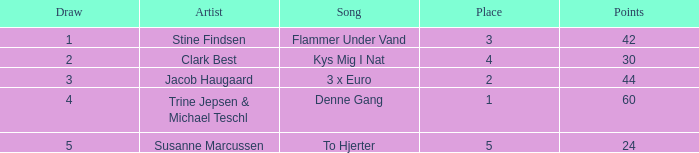What is the smallest draw when the artist is stine findsen and the points are greater than 42? None. 